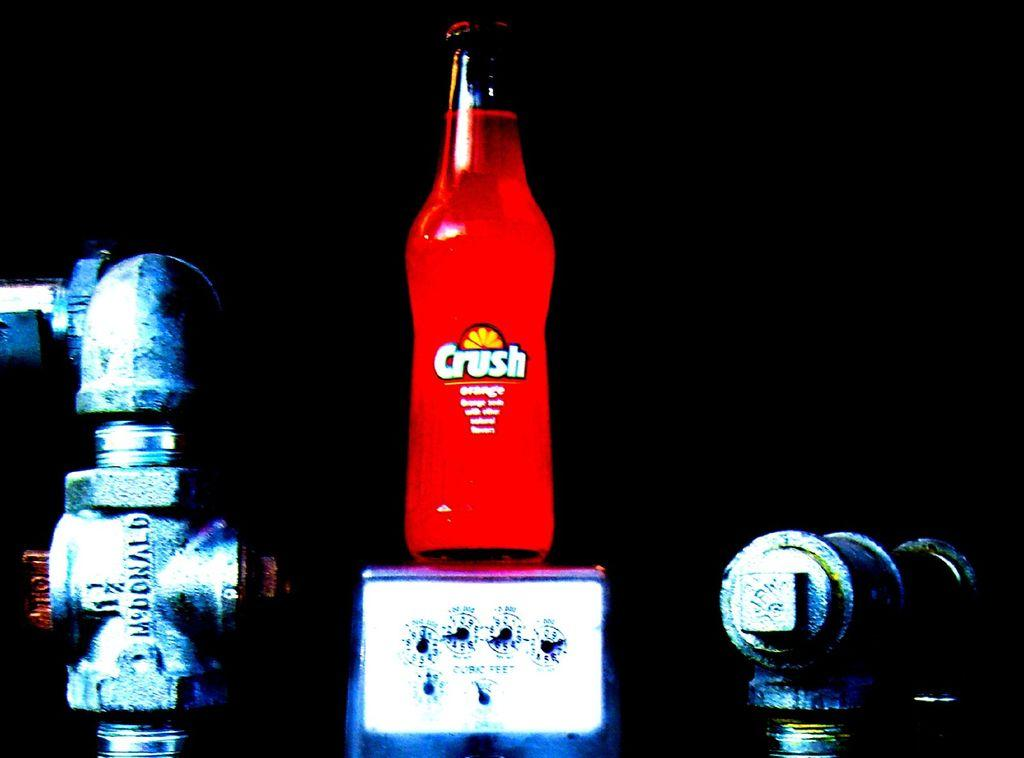What is on the bottle in the image? There is a sticker on the bottle in the image. What is inside the bottle? The bottle contains a red-colored drink. What other object can be seen in the image? There is a steel rod in the image. What device is present in the image? There is a meter in the image. What type of society is depicted in the image? There is no depiction of a society in the image; it features a bottle with a sticker, a red-colored drink, a steel rod, and a meter. 